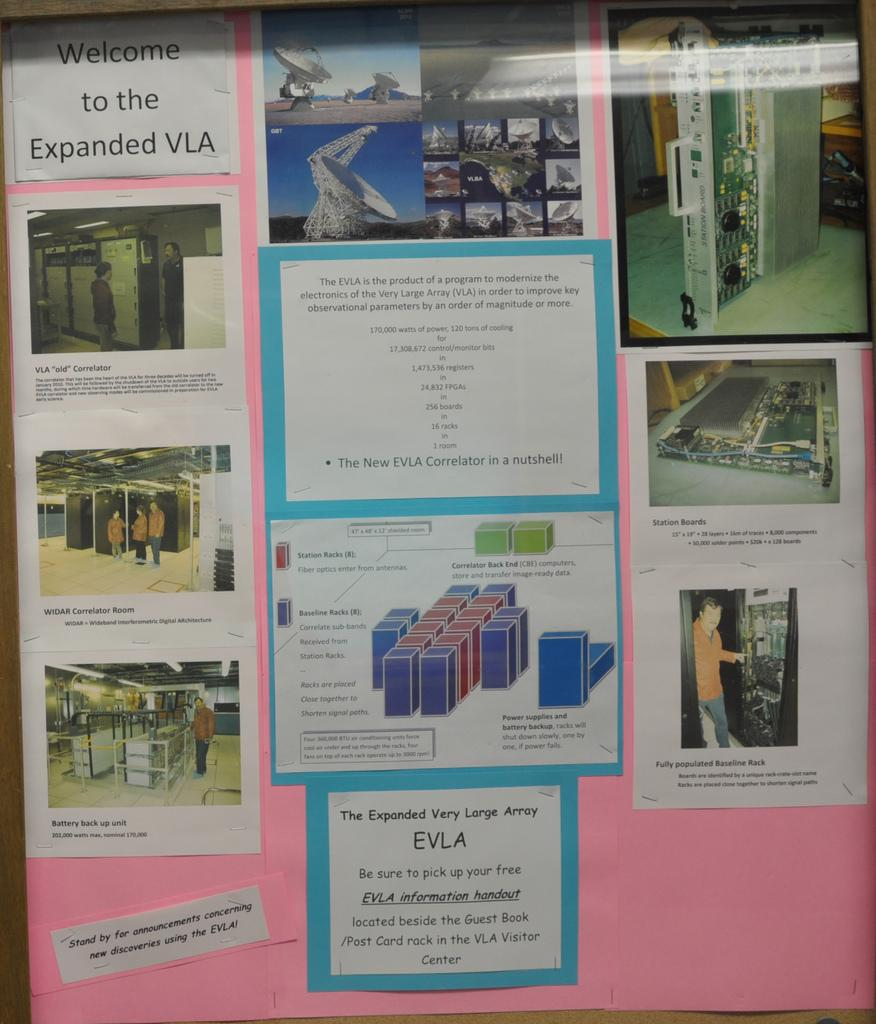<image>
Render a clear and concise summary of the photo. a poster board that has a paper posted to it on the top that says 'welcome to the expanded VLA' 